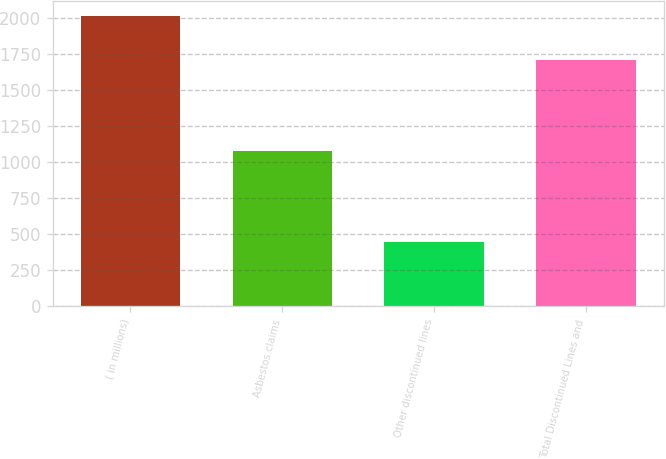<chart> <loc_0><loc_0><loc_500><loc_500><bar_chart><fcel>( in millions)<fcel>Asbestos claims<fcel>Other discontinued lines<fcel>Total Discontinued Lines and<nl><fcel>2012<fcel>1078<fcel>444<fcel>1707<nl></chart> 